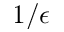<formula> <loc_0><loc_0><loc_500><loc_500>1 / \epsilon</formula> 